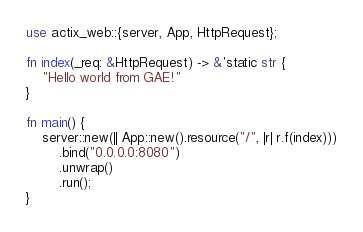Convert code to text. <code><loc_0><loc_0><loc_500><loc_500><_Rust_>use actix_web::{server, App, HttpRequest};

fn index(_req: &HttpRequest) -> &'static str {
    "Hello world from GAE!"
}

fn main() {
    server::new(|| App::new().resource("/", |r| r.f(index)))
        .bind("0.0.0.0:8080")
        .unwrap()
        .run();
}
</code> 